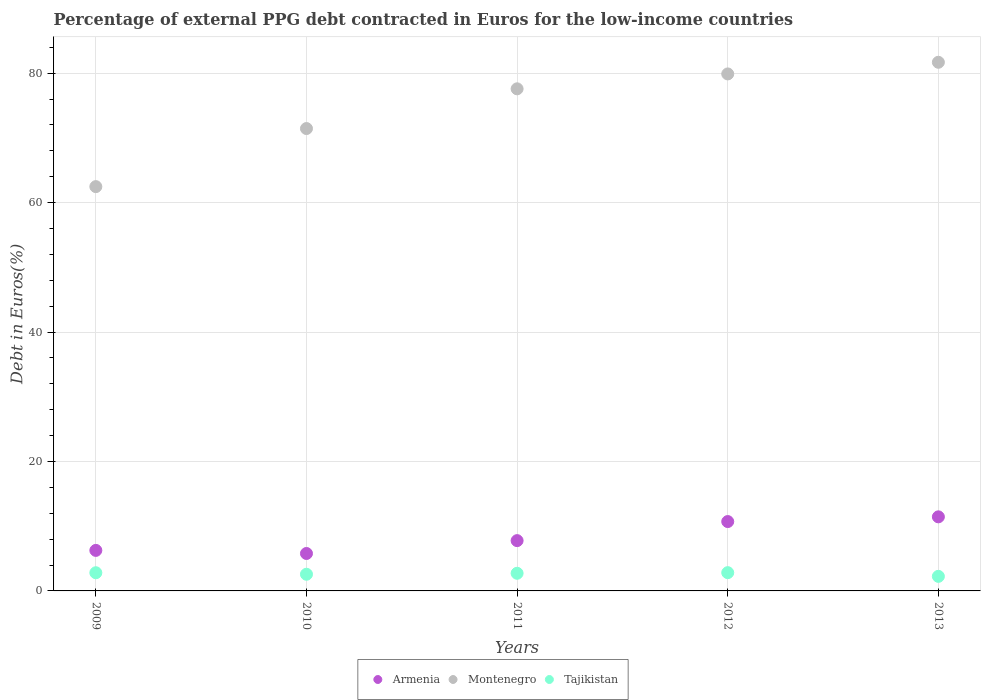How many different coloured dotlines are there?
Your response must be concise. 3. What is the percentage of external PPG debt contracted in Euros in Tajikistan in 2013?
Your response must be concise. 2.25. Across all years, what is the maximum percentage of external PPG debt contracted in Euros in Armenia?
Offer a terse response. 11.45. Across all years, what is the minimum percentage of external PPG debt contracted in Euros in Montenegro?
Your answer should be very brief. 62.47. In which year was the percentage of external PPG debt contracted in Euros in Tajikistan minimum?
Offer a terse response. 2013. What is the total percentage of external PPG debt contracted in Euros in Tajikistan in the graph?
Your answer should be very brief. 13.18. What is the difference between the percentage of external PPG debt contracted in Euros in Tajikistan in 2010 and that in 2011?
Your response must be concise. -0.15. What is the difference between the percentage of external PPG debt contracted in Euros in Tajikistan in 2010 and the percentage of external PPG debt contracted in Euros in Armenia in 2009?
Provide a succinct answer. -3.69. What is the average percentage of external PPG debt contracted in Euros in Montenegro per year?
Offer a terse response. 74.61. In the year 2009, what is the difference between the percentage of external PPG debt contracted in Euros in Armenia and percentage of external PPG debt contracted in Euros in Montenegro?
Offer a very short reply. -56.21. What is the ratio of the percentage of external PPG debt contracted in Euros in Montenegro in 2009 to that in 2013?
Your answer should be very brief. 0.76. Is the percentage of external PPG debt contracted in Euros in Armenia in 2009 less than that in 2010?
Provide a succinct answer. No. Is the difference between the percentage of external PPG debt contracted in Euros in Armenia in 2010 and 2012 greater than the difference between the percentage of external PPG debt contracted in Euros in Montenegro in 2010 and 2012?
Make the answer very short. Yes. What is the difference between the highest and the second highest percentage of external PPG debt contracted in Euros in Montenegro?
Your answer should be very brief. 1.8. What is the difference between the highest and the lowest percentage of external PPG debt contracted in Euros in Tajikistan?
Your answer should be compact. 0.57. In how many years, is the percentage of external PPG debt contracted in Euros in Tajikistan greater than the average percentage of external PPG debt contracted in Euros in Tajikistan taken over all years?
Give a very brief answer. 3. Is the sum of the percentage of external PPG debt contracted in Euros in Montenegro in 2011 and 2012 greater than the maximum percentage of external PPG debt contracted in Euros in Tajikistan across all years?
Provide a succinct answer. Yes. Does the percentage of external PPG debt contracted in Euros in Armenia monotonically increase over the years?
Your answer should be very brief. No. Is the percentage of external PPG debt contracted in Euros in Armenia strictly greater than the percentage of external PPG debt contracted in Euros in Tajikistan over the years?
Offer a very short reply. Yes. Is the percentage of external PPG debt contracted in Euros in Armenia strictly less than the percentage of external PPG debt contracted in Euros in Montenegro over the years?
Offer a terse response. Yes. How many years are there in the graph?
Make the answer very short. 5. Are the values on the major ticks of Y-axis written in scientific E-notation?
Provide a succinct answer. No. Does the graph contain any zero values?
Your answer should be very brief. No. How are the legend labels stacked?
Offer a terse response. Horizontal. What is the title of the graph?
Provide a succinct answer. Percentage of external PPG debt contracted in Euros for the low-income countries. What is the label or title of the Y-axis?
Offer a terse response. Debt in Euros(%). What is the Debt in Euros(%) in Armenia in 2009?
Your answer should be compact. 6.26. What is the Debt in Euros(%) of Montenegro in 2009?
Your answer should be compact. 62.47. What is the Debt in Euros(%) in Tajikistan in 2009?
Ensure brevity in your answer.  2.81. What is the Debt in Euros(%) in Armenia in 2010?
Offer a very short reply. 5.78. What is the Debt in Euros(%) in Montenegro in 2010?
Offer a very short reply. 71.45. What is the Debt in Euros(%) in Tajikistan in 2010?
Give a very brief answer. 2.58. What is the Debt in Euros(%) in Armenia in 2011?
Your answer should be very brief. 7.77. What is the Debt in Euros(%) in Montenegro in 2011?
Keep it short and to the point. 77.58. What is the Debt in Euros(%) of Tajikistan in 2011?
Provide a succinct answer. 2.73. What is the Debt in Euros(%) of Armenia in 2012?
Your response must be concise. 10.72. What is the Debt in Euros(%) in Montenegro in 2012?
Provide a succinct answer. 79.89. What is the Debt in Euros(%) in Tajikistan in 2012?
Offer a terse response. 2.82. What is the Debt in Euros(%) in Armenia in 2013?
Keep it short and to the point. 11.45. What is the Debt in Euros(%) in Montenegro in 2013?
Your answer should be very brief. 81.69. What is the Debt in Euros(%) of Tajikistan in 2013?
Your answer should be compact. 2.25. Across all years, what is the maximum Debt in Euros(%) of Armenia?
Your response must be concise. 11.45. Across all years, what is the maximum Debt in Euros(%) of Montenegro?
Your answer should be very brief. 81.69. Across all years, what is the maximum Debt in Euros(%) of Tajikistan?
Provide a succinct answer. 2.82. Across all years, what is the minimum Debt in Euros(%) in Armenia?
Your answer should be compact. 5.78. Across all years, what is the minimum Debt in Euros(%) of Montenegro?
Provide a succinct answer. 62.47. Across all years, what is the minimum Debt in Euros(%) of Tajikistan?
Offer a terse response. 2.25. What is the total Debt in Euros(%) of Armenia in the graph?
Offer a terse response. 41.98. What is the total Debt in Euros(%) in Montenegro in the graph?
Provide a short and direct response. 373.07. What is the total Debt in Euros(%) in Tajikistan in the graph?
Offer a terse response. 13.18. What is the difference between the Debt in Euros(%) of Armenia in 2009 and that in 2010?
Give a very brief answer. 0.48. What is the difference between the Debt in Euros(%) of Montenegro in 2009 and that in 2010?
Offer a very short reply. -8.98. What is the difference between the Debt in Euros(%) of Tajikistan in 2009 and that in 2010?
Make the answer very short. 0.23. What is the difference between the Debt in Euros(%) of Armenia in 2009 and that in 2011?
Your answer should be very brief. -1.51. What is the difference between the Debt in Euros(%) of Montenegro in 2009 and that in 2011?
Your answer should be very brief. -15.11. What is the difference between the Debt in Euros(%) of Tajikistan in 2009 and that in 2011?
Ensure brevity in your answer.  0.08. What is the difference between the Debt in Euros(%) in Armenia in 2009 and that in 2012?
Your response must be concise. -4.46. What is the difference between the Debt in Euros(%) of Montenegro in 2009 and that in 2012?
Offer a terse response. -17.41. What is the difference between the Debt in Euros(%) in Tajikistan in 2009 and that in 2012?
Your answer should be compact. -0.01. What is the difference between the Debt in Euros(%) of Armenia in 2009 and that in 2013?
Provide a succinct answer. -5.18. What is the difference between the Debt in Euros(%) in Montenegro in 2009 and that in 2013?
Your answer should be compact. -19.21. What is the difference between the Debt in Euros(%) of Tajikistan in 2009 and that in 2013?
Keep it short and to the point. 0.56. What is the difference between the Debt in Euros(%) in Armenia in 2010 and that in 2011?
Make the answer very short. -1.99. What is the difference between the Debt in Euros(%) of Montenegro in 2010 and that in 2011?
Offer a very short reply. -6.14. What is the difference between the Debt in Euros(%) of Tajikistan in 2010 and that in 2011?
Provide a short and direct response. -0.15. What is the difference between the Debt in Euros(%) in Armenia in 2010 and that in 2012?
Provide a succinct answer. -4.93. What is the difference between the Debt in Euros(%) of Montenegro in 2010 and that in 2012?
Your response must be concise. -8.44. What is the difference between the Debt in Euros(%) of Tajikistan in 2010 and that in 2012?
Make the answer very short. -0.25. What is the difference between the Debt in Euros(%) of Armenia in 2010 and that in 2013?
Offer a very short reply. -5.66. What is the difference between the Debt in Euros(%) of Montenegro in 2010 and that in 2013?
Ensure brevity in your answer.  -10.24. What is the difference between the Debt in Euros(%) of Tajikistan in 2010 and that in 2013?
Give a very brief answer. 0.33. What is the difference between the Debt in Euros(%) in Armenia in 2011 and that in 2012?
Make the answer very short. -2.95. What is the difference between the Debt in Euros(%) in Montenegro in 2011 and that in 2012?
Provide a succinct answer. -2.3. What is the difference between the Debt in Euros(%) of Tajikistan in 2011 and that in 2012?
Keep it short and to the point. -0.1. What is the difference between the Debt in Euros(%) of Armenia in 2011 and that in 2013?
Ensure brevity in your answer.  -3.68. What is the difference between the Debt in Euros(%) of Montenegro in 2011 and that in 2013?
Offer a very short reply. -4.1. What is the difference between the Debt in Euros(%) in Tajikistan in 2011 and that in 2013?
Offer a very short reply. 0.47. What is the difference between the Debt in Euros(%) of Armenia in 2012 and that in 2013?
Offer a terse response. -0.73. What is the difference between the Debt in Euros(%) in Montenegro in 2012 and that in 2013?
Make the answer very short. -1.8. What is the difference between the Debt in Euros(%) in Tajikistan in 2012 and that in 2013?
Keep it short and to the point. 0.57. What is the difference between the Debt in Euros(%) of Armenia in 2009 and the Debt in Euros(%) of Montenegro in 2010?
Your answer should be very brief. -65.18. What is the difference between the Debt in Euros(%) of Armenia in 2009 and the Debt in Euros(%) of Tajikistan in 2010?
Provide a short and direct response. 3.69. What is the difference between the Debt in Euros(%) of Montenegro in 2009 and the Debt in Euros(%) of Tajikistan in 2010?
Keep it short and to the point. 59.89. What is the difference between the Debt in Euros(%) of Armenia in 2009 and the Debt in Euros(%) of Montenegro in 2011?
Provide a short and direct response. -71.32. What is the difference between the Debt in Euros(%) in Armenia in 2009 and the Debt in Euros(%) in Tajikistan in 2011?
Give a very brief answer. 3.54. What is the difference between the Debt in Euros(%) in Montenegro in 2009 and the Debt in Euros(%) in Tajikistan in 2011?
Ensure brevity in your answer.  59.74. What is the difference between the Debt in Euros(%) of Armenia in 2009 and the Debt in Euros(%) of Montenegro in 2012?
Offer a terse response. -73.62. What is the difference between the Debt in Euros(%) of Armenia in 2009 and the Debt in Euros(%) of Tajikistan in 2012?
Make the answer very short. 3.44. What is the difference between the Debt in Euros(%) in Montenegro in 2009 and the Debt in Euros(%) in Tajikistan in 2012?
Keep it short and to the point. 59.65. What is the difference between the Debt in Euros(%) of Armenia in 2009 and the Debt in Euros(%) of Montenegro in 2013?
Make the answer very short. -75.42. What is the difference between the Debt in Euros(%) of Armenia in 2009 and the Debt in Euros(%) of Tajikistan in 2013?
Keep it short and to the point. 4.01. What is the difference between the Debt in Euros(%) in Montenegro in 2009 and the Debt in Euros(%) in Tajikistan in 2013?
Your answer should be very brief. 60.22. What is the difference between the Debt in Euros(%) in Armenia in 2010 and the Debt in Euros(%) in Montenegro in 2011?
Offer a very short reply. -71.8. What is the difference between the Debt in Euros(%) in Armenia in 2010 and the Debt in Euros(%) in Tajikistan in 2011?
Provide a short and direct response. 3.06. What is the difference between the Debt in Euros(%) in Montenegro in 2010 and the Debt in Euros(%) in Tajikistan in 2011?
Give a very brief answer. 68.72. What is the difference between the Debt in Euros(%) of Armenia in 2010 and the Debt in Euros(%) of Montenegro in 2012?
Offer a very short reply. -74.1. What is the difference between the Debt in Euros(%) of Armenia in 2010 and the Debt in Euros(%) of Tajikistan in 2012?
Provide a short and direct response. 2.96. What is the difference between the Debt in Euros(%) of Montenegro in 2010 and the Debt in Euros(%) of Tajikistan in 2012?
Your answer should be very brief. 68.62. What is the difference between the Debt in Euros(%) of Armenia in 2010 and the Debt in Euros(%) of Montenegro in 2013?
Keep it short and to the point. -75.9. What is the difference between the Debt in Euros(%) of Armenia in 2010 and the Debt in Euros(%) of Tajikistan in 2013?
Provide a short and direct response. 3.53. What is the difference between the Debt in Euros(%) in Montenegro in 2010 and the Debt in Euros(%) in Tajikistan in 2013?
Your answer should be very brief. 69.19. What is the difference between the Debt in Euros(%) of Armenia in 2011 and the Debt in Euros(%) of Montenegro in 2012?
Provide a succinct answer. -72.11. What is the difference between the Debt in Euros(%) of Armenia in 2011 and the Debt in Euros(%) of Tajikistan in 2012?
Make the answer very short. 4.95. What is the difference between the Debt in Euros(%) in Montenegro in 2011 and the Debt in Euros(%) in Tajikistan in 2012?
Your answer should be very brief. 74.76. What is the difference between the Debt in Euros(%) of Armenia in 2011 and the Debt in Euros(%) of Montenegro in 2013?
Your response must be concise. -73.91. What is the difference between the Debt in Euros(%) of Armenia in 2011 and the Debt in Euros(%) of Tajikistan in 2013?
Your response must be concise. 5.52. What is the difference between the Debt in Euros(%) of Montenegro in 2011 and the Debt in Euros(%) of Tajikistan in 2013?
Give a very brief answer. 75.33. What is the difference between the Debt in Euros(%) in Armenia in 2012 and the Debt in Euros(%) in Montenegro in 2013?
Offer a terse response. -70.97. What is the difference between the Debt in Euros(%) of Armenia in 2012 and the Debt in Euros(%) of Tajikistan in 2013?
Give a very brief answer. 8.47. What is the difference between the Debt in Euros(%) of Montenegro in 2012 and the Debt in Euros(%) of Tajikistan in 2013?
Offer a terse response. 77.63. What is the average Debt in Euros(%) of Armenia per year?
Provide a short and direct response. 8.4. What is the average Debt in Euros(%) of Montenegro per year?
Your answer should be compact. 74.61. What is the average Debt in Euros(%) in Tajikistan per year?
Provide a short and direct response. 2.64. In the year 2009, what is the difference between the Debt in Euros(%) in Armenia and Debt in Euros(%) in Montenegro?
Make the answer very short. -56.21. In the year 2009, what is the difference between the Debt in Euros(%) in Armenia and Debt in Euros(%) in Tajikistan?
Keep it short and to the point. 3.45. In the year 2009, what is the difference between the Debt in Euros(%) of Montenegro and Debt in Euros(%) of Tajikistan?
Ensure brevity in your answer.  59.66. In the year 2010, what is the difference between the Debt in Euros(%) of Armenia and Debt in Euros(%) of Montenegro?
Keep it short and to the point. -65.66. In the year 2010, what is the difference between the Debt in Euros(%) in Armenia and Debt in Euros(%) in Tajikistan?
Provide a short and direct response. 3.21. In the year 2010, what is the difference between the Debt in Euros(%) in Montenegro and Debt in Euros(%) in Tajikistan?
Provide a short and direct response. 68.87. In the year 2011, what is the difference between the Debt in Euros(%) in Armenia and Debt in Euros(%) in Montenegro?
Provide a succinct answer. -69.81. In the year 2011, what is the difference between the Debt in Euros(%) in Armenia and Debt in Euros(%) in Tajikistan?
Give a very brief answer. 5.05. In the year 2011, what is the difference between the Debt in Euros(%) of Montenegro and Debt in Euros(%) of Tajikistan?
Your answer should be very brief. 74.86. In the year 2012, what is the difference between the Debt in Euros(%) of Armenia and Debt in Euros(%) of Montenegro?
Offer a terse response. -69.17. In the year 2012, what is the difference between the Debt in Euros(%) of Armenia and Debt in Euros(%) of Tajikistan?
Your answer should be compact. 7.9. In the year 2012, what is the difference between the Debt in Euros(%) in Montenegro and Debt in Euros(%) in Tajikistan?
Your answer should be compact. 77.06. In the year 2013, what is the difference between the Debt in Euros(%) of Armenia and Debt in Euros(%) of Montenegro?
Provide a short and direct response. -70.24. In the year 2013, what is the difference between the Debt in Euros(%) of Armenia and Debt in Euros(%) of Tajikistan?
Provide a short and direct response. 9.2. In the year 2013, what is the difference between the Debt in Euros(%) in Montenegro and Debt in Euros(%) in Tajikistan?
Keep it short and to the point. 79.43. What is the ratio of the Debt in Euros(%) of Armenia in 2009 to that in 2010?
Offer a terse response. 1.08. What is the ratio of the Debt in Euros(%) in Montenegro in 2009 to that in 2010?
Ensure brevity in your answer.  0.87. What is the ratio of the Debt in Euros(%) of Tajikistan in 2009 to that in 2010?
Your response must be concise. 1.09. What is the ratio of the Debt in Euros(%) of Armenia in 2009 to that in 2011?
Provide a succinct answer. 0.81. What is the ratio of the Debt in Euros(%) in Montenegro in 2009 to that in 2011?
Your response must be concise. 0.81. What is the ratio of the Debt in Euros(%) in Tajikistan in 2009 to that in 2011?
Provide a succinct answer. 1.03. What is the ratio of the Debt in Euros(%) in Armenia in 2009 to that in 2012?
Your answer should be very brief. 0.58. What is the ratio of the Debt in Euros(%) in Montenegro in 2009 to that in 2012?
Your answer should be very brief. 0.78. What is the ratio of the Debt in Euros(%) in Armenia in 2009 to that in 2013?
Offer a terse response. 0.55. What is the ratio of the Debt in Euros(%) in Montenegro in 2009 to that in 2013?
Provide a short and direct response. 0.76. What is the ratio of the Debt in Euros(%) in Tajikistan in 2009 to that in 2013?
Provide a short and direct response. 1.25. What is the ratio of the Debt in Euros(%) of Armenia in 2010 to that in 2011?
Offer a very short reply. 0.74. What is the ratio of the Debt in Euros(%) in Montenegro in 2010 to that in 2011?
Ensure brevity in your answer.  0.92. What is the ratio of the Debt in Euros(%) in Tajikistan in 2010 to that in 2011?
Provide a short and direct response. 0.95. What is the ratio of the Debt in Euros(%) in Armenia in 2010 to that in 2012?
Your response must be concise. 0.54. What is the ratio of the Debt in Euros(%) in Montenegro in 2010 to that in 2012?
Your response must be concise. 0.89. What is the ratio of the Debt in Euros(%) of Tajikistan in 2010 to that in 2012?
Give a very brief answer. 0.91. What is the ratio of the Debt in Euros(%) of Armenia in 2010 to that in 2013?
Offer a terse response. 0.51. What is the ratio of the Debt in Euros(%) of Montenegro in 2010 to that in 2013?
Your answer should be very brief. 0.87. What is the ratio of the Debt in Euros(%) of Tajikistan in 2010 to that in 2013?
Your answer should be very brief. 1.14. What is the ratio of the Debt in Euros(%) of Armenia in 2011 to that in 2012?
Offer a terse response. 0.73. What is the ratio of the Debt in Euros(%) in Montenegro in 2011 to that in 2012?
Ensure brevity in your answer.  0.97. What is the ratio of the Debt in Euros(%) of Tajikistan in 2011 to that in 2012?
Offer a very short reply. 0.97. What is the ratio of the Debt in Euros(%) in Armenia in 2011 to that in 2013?
Your answer should be very brief. 0.68. What is the ratio of the Debt in Euros(%) of Montenegro in 2011 to that in 2013?
Offer a terse response. 0.95. What is the ratio of the Debt in Euros(%) in Tajikistan in 2011 to that in 2013?
Your response must be concise. 1.21. What is the ratio of the Debt in Euros(%) of Armenia in 2012 to that in 2013?
Provide a succinct answer. 0.94. What is the ratio of the Debt in Euros(%) of Tajikistan in 2012 to that in 2013?
Provide a short and direct response. 1.25. What is the difference between the highest and the second highest Debt in Euros(%) in Armenia?
Give a very brief answer. 0.73. What is the difference between the highest and the second highest Debt in Euros(%) in Montenegro?
Provide a short and direct response. 1.8. What is the difference between the highest and the second highest Debt in Euros(%) in Tajikistan?
Your response must be concise. 0.01. What is the difference between the highest and the lowest Debt in Euros(%) in Armenia?
Provide a succinct answer. 5.66. What is the difference between the highest and the lowest Debt in Euros(%) of Montenegro?
Provide a short and direct response. 19.21. What is the difference between the highest and the lowest Debt in Euros(%) in Tajikistan?
Make the answer very short. 0.57. 